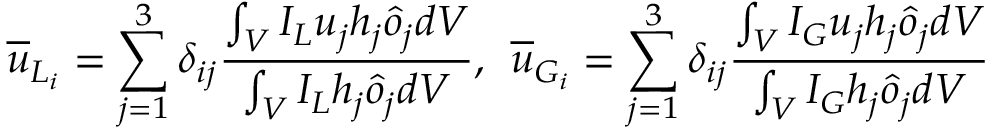Convert formula to latex. <formula><loc_0><loc_0><loc_500><loc_500>\overline { u } _ { L _ { i } } = \sum _ { j = 1 } ^ { 3 } \delta _ { i j } \frac { \int _ { V } I _ { L } u _ { j } h _ { j } \hat { o } _ { j } d V } { \int _ { V } I _ { L } h _ { j } \hat { o } _ { j } d V } , \, \overline { u } _ { G _ { i } } = \sum _ { j = 1 } ^ { 3 } \delta _ { i j } \frac { \int _ { V } I _ { G } u _ { j } h _ { j } \hat { o } _ { j } d V } { \int _ { V } I _ { G } h _ { j } \hat { o } _ { j } d V }</formula> 